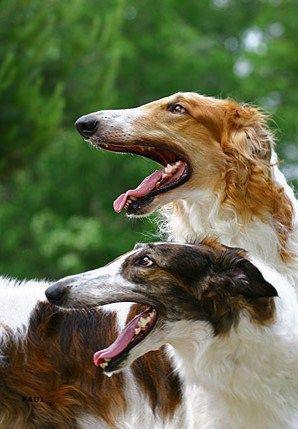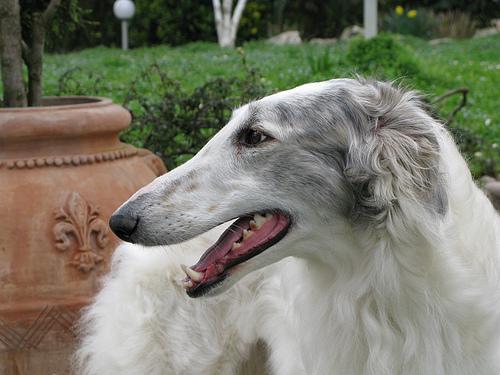The first image is the image on the left, the second image is the image on the right. Given the left and right images, does the statement "All hound dogs have their heads turned to the left, and at least two dogs have open mouths." hold true? Answer yes or no. Yes. The first image is the image on the left, the second image is the image on the right. Assess this claim about the two images: "The left image contains exactly two dogs.". Correct or not? Answer yes or no. Yes. 